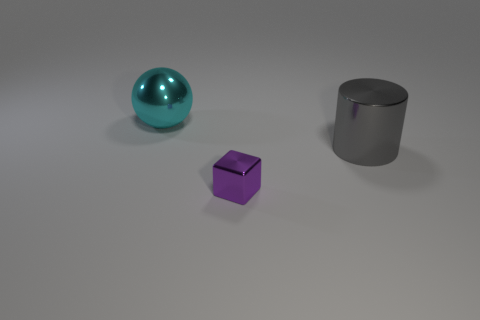Add 1 yellow shiny cubes. How many objects exist? 4 Add 1 balls. How many balls exist? 2 Subtract 0 green balls. How many objects are left? 3 Subtract all blocks. How many objects are left? 2 Subtract 1 cylinders. How many cylinders are left? 0 Subtract all green spheres. Subtract all blue cylinders. How many spheres are left? 1 Subtract all purple cylinders. How many green cubes are left? 0 Subtract all big cyan matte balls. Subtract all big cyan shiny objects. How many objects are left? 2 Add 2 spheres. How many spheres are left? 3 